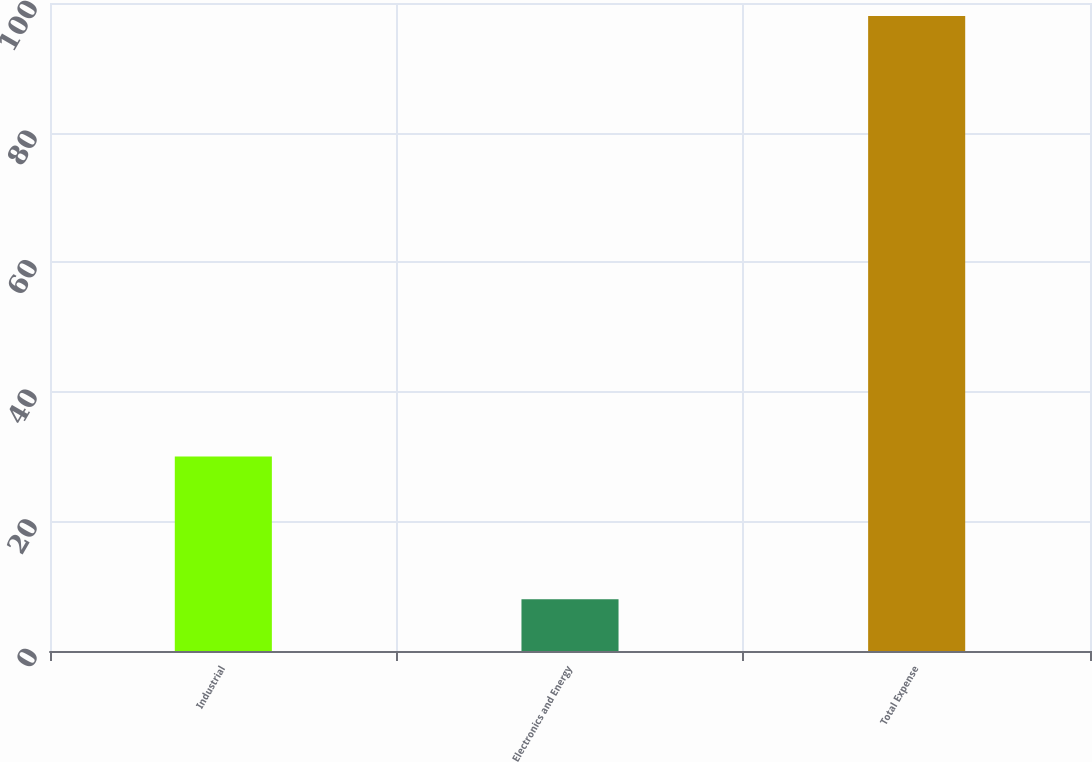Convert chart to OTSL. <chart><loc_0><loc_0><loc_500><loc_500><bar_chart><fcel>Industrial<fcel>Electronics and Energy<fcel>Total Expense<nl><fcel>30<fcel>8<fcel>98<nl></chart> 